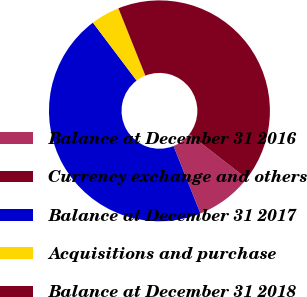Convert chart. <chart><loc_0><loc_0><loc_500><loc_500><pie_chart><fcel>Balance at December 31 2016<fcel>Currency exchange and others<fcel>Balance at December 31 2017<fcel>Acquisitions and purchase<fcel>Balance at December 31 2018<nl><fcel>8.43%<fcel>0.02%<fcel>45.76%<fcel>4.23%<fcel>41.56%<nl></chart> 